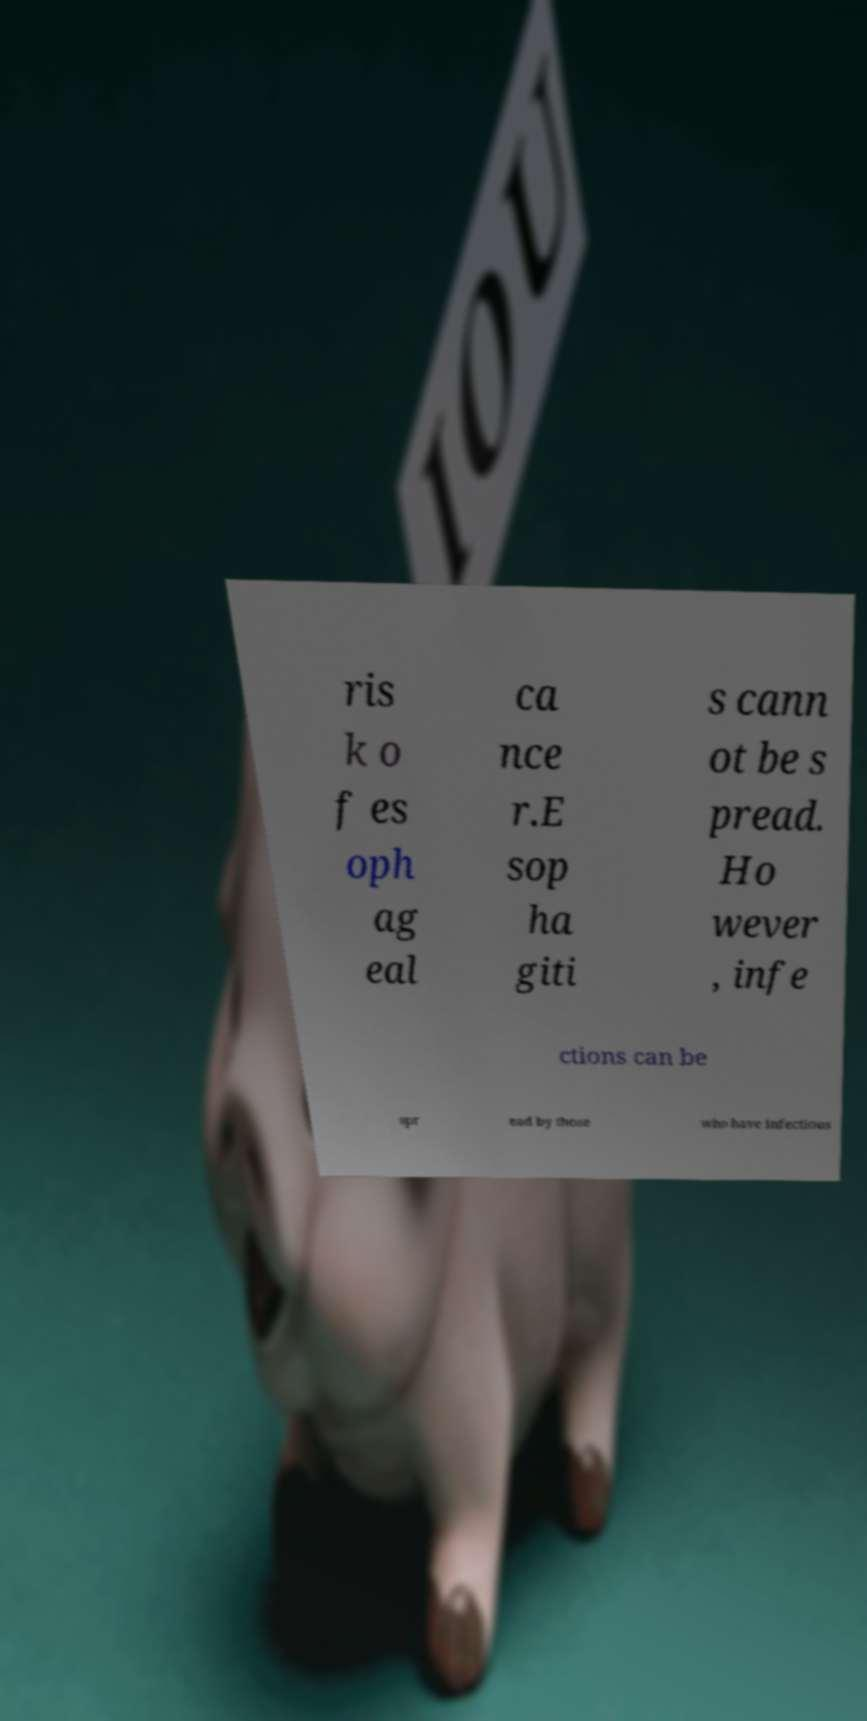There's text embedded in this image that I need extracted. Can you transcribe it verbatim? ris k o f es oph ag eal ca nce r.E sop ha giti s cann ot be s pread. Ho wever , infe ctions can be spr ead by those who have infectious 